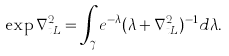Convert formula to latex. <formula><loc_0><loc_0><loc_500><loc_500>\exp \nabla _ { t L } ^ { 2 } = \int _ { \gamma } e ^ { - \lambda } ( \lambda + \nabla _ { t L } ^ { 2 } ) ^ { - 1 } d \lambda .</formula> 